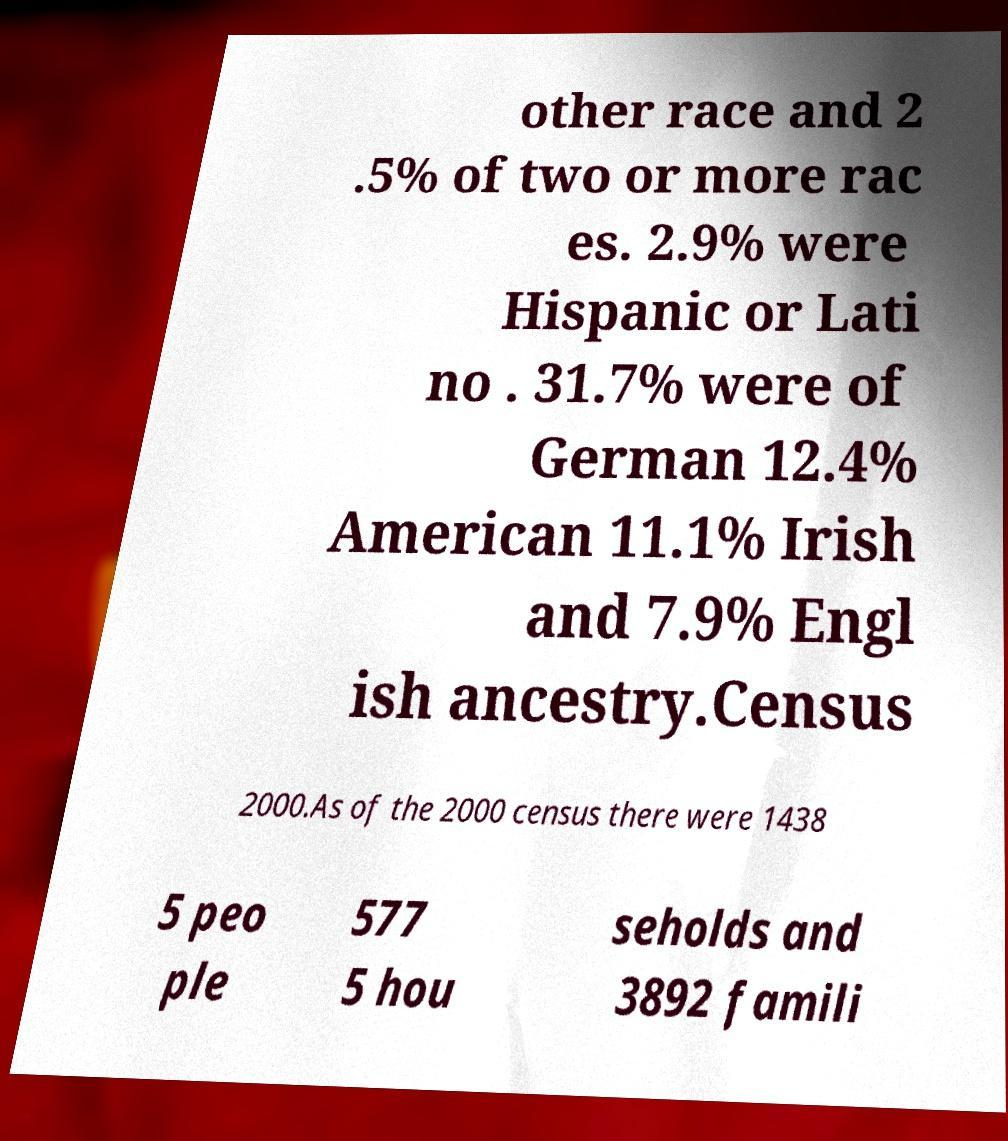What messages or text are displayed in this image? I need them in a readable, typed format. other race and 2 .5% of two or more rac es. 2.9% were Hispanic or Lati no . 31.7% were of German 12.4% American 11.1% Irish and 7.9% Engl ish ancestry.Census 2000.As of the 2000 census there were 1438 5 peo ple 577 5 hou seholds and 3892 famili 